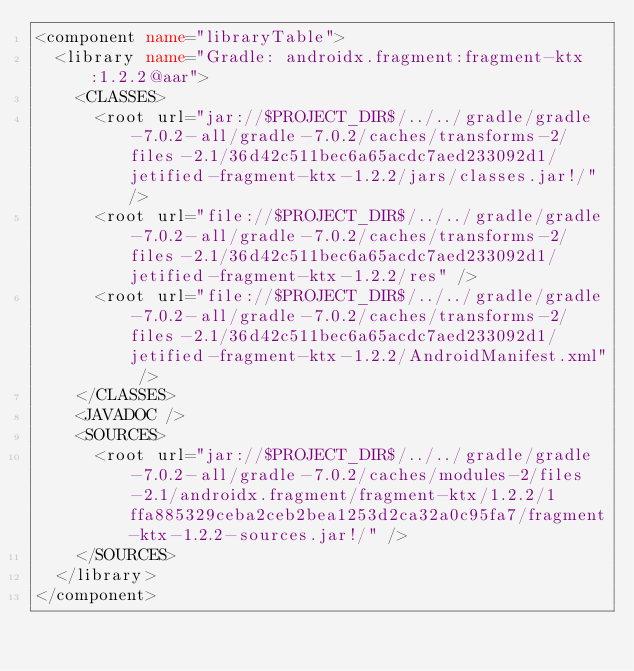<code> <loc_0><loc_0><loc_500><loc_500><_XML_><component name="libraryTable">
  <library name="Gradle: androidx.fragment:fragment-ktx:1.2.2@aar">
    <CLASSES>
      <root url="jar://$PROJECT_DIR$/../../gradle/gradle-7.0.2-all/gradle-7.0.2/caches/transforms-2/files-2.1/36d42c511bec6a65acdc7aed233092d1/jetified-fragment-ktx-1.2.2/jars/classes.jar!/" />
      <root url="file://$PROJECT_DIR$/../../gradle/gradle-7.0.2-all/gradle-7.0.2/caches/transforms-2/files-2.1/36d42c511bec6a65acdc7aed233092d1/jetified-fragment-ktx-1.2.2/res" />
      <root url="file://$PROJECT_DIR$/../../gradle/gradle-7.0.2-all/gradle-7.0.2/caches/transforms-2/files-2.1/36d42c511bec6a65acdc7aed233092d1/jetified-fragment-ktx-1.2.2/AndroidManifest.xml" />
    </CLASSES>
    <JAVADOC />
    <SOURCES>
      <root url="jar://$PROJECT_DIR$/../../gradle/gradle-7.0.2-all/gradle-7.0.2/caches/modules-2/files-2.1/androidx.fragment/fragment-ktx/1.2.2/1ffa885329ceba2ceb2bea1253d2ca32a0c95fa7/fragment-ktx-1.2.2-sources.jar!/" />
    </SOURCES>
  </library>
</component></code> 